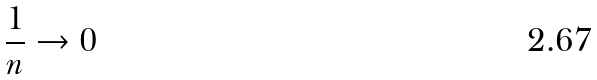<formula> <loc_0><loc_0><loc_500><loc_500>\frac { 1 } { n } \rightarrow 0</formula> 